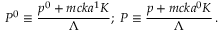<formula> <loc_0><loc_0><loc_500><loc_500>P ^ { 0 } \equiv \frac { p ^ { 0 } + m c k a ^ { 1 } K } { \Lambda } ; \, P \equiv \frac { p + m c k a ^ { 0 } K } { \Lambda } \, .</formula> 